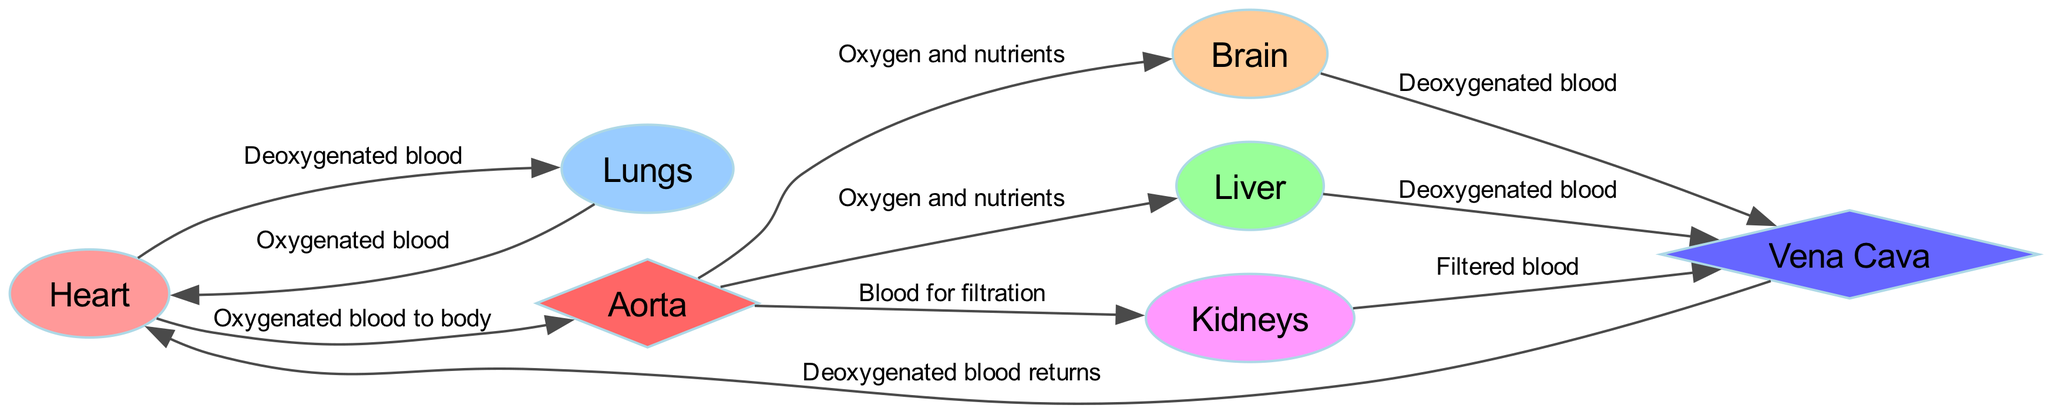What organ does deoxygenated blood flow to from the heart? The diagram shows that deoxygenated blood flows from the heart to the lungs. This is directly indicated by the edge connecting the "heart" node to the "lungs" node with the label "Deoxygenated blood."
Answer: Lungs How many nodes are present in the diagram? To find the number of nodes, we can count each labeled organ or structure in the diagram. The nodes listed are: heart, lungs, brain, liver, kidneys, aorta, and vena cava. This gives us a total of 7 nodes.
Answer: 7 What type of blood does the aorta carry? The edges leading from the heart to the aorta indicate that the aorta carries oxygenated blood to the body. Specifically, the edge is labeled "Oxygenated blood to body." Therefore, the aorta transports oxygen-rich blood.
Answer: Oxygenated blood Which organ receives oxygen and nutrients from the aorta? According to the diagram, the edges from the aorta lead to multiple organs. Both the brain and liver are connected to the aorta with edges labeled "Oxygen and nutrients." Thus, both organs receive oxygen and nutrients via the aorta.
Answer: Brain, Liver Where does deoxygenated blood return after passing through the brain? The diagram illustrates that deoxygenated blood flows from the brain to the vena cava, as indicated by the edge labeled "Deoxygenated blood." Therefore, after passing through the brain, the deoxygenated blood returns to the vena cava.
Answer: Vena cava What happens to the blood after it is filtered by the kidneys? The diagram shows that filtered blood from the kidneys flows to the vena cava, as indicated by the edge labeled "Filtered blood." Therefore, after filtration, the blood returns to the vena cava.
Answer: Vena cava What type of blood does the vena cava carry back to the heart? The diagram indicates that the vena cava carries deoxygenated blood back to the heart, as labeled on the edge connecting the vena cava to the heart with "Deoxygenated blood returns."
Answer: Deoxygenated blood What is the relationship between the lungs and the heart? The diagram shows a direct connection where deoxygenated blood moves from the heart to the lungs and oxygenated blood returns from the lungs to the heart. This is indicated by the edges and their respective labels. Thus, the lungs and heart share a reciprocal relationship in terms of blood flow.
Answer: Reciprocal relationship 